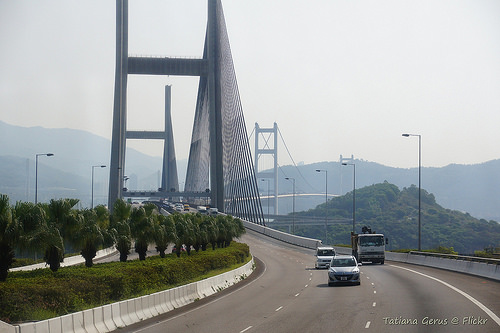<image>
Is the car behind the car? Yes. From this viewpoint, the car is positioned behind the car, with the car partially or fully occluding the car. 